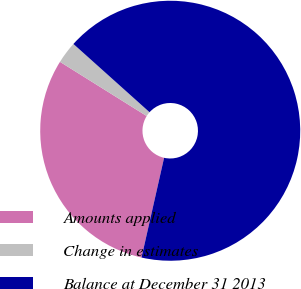<chart> <loc_0><loc_0><loc_500><loc_500><pie_chart><fcel>Amounts applied<fcel>Change in estimates<fcel>Balance at December 31 2013<nl><fcel>30.35%<fcel>2.74%<fcel>66.91%<nl></chart> 